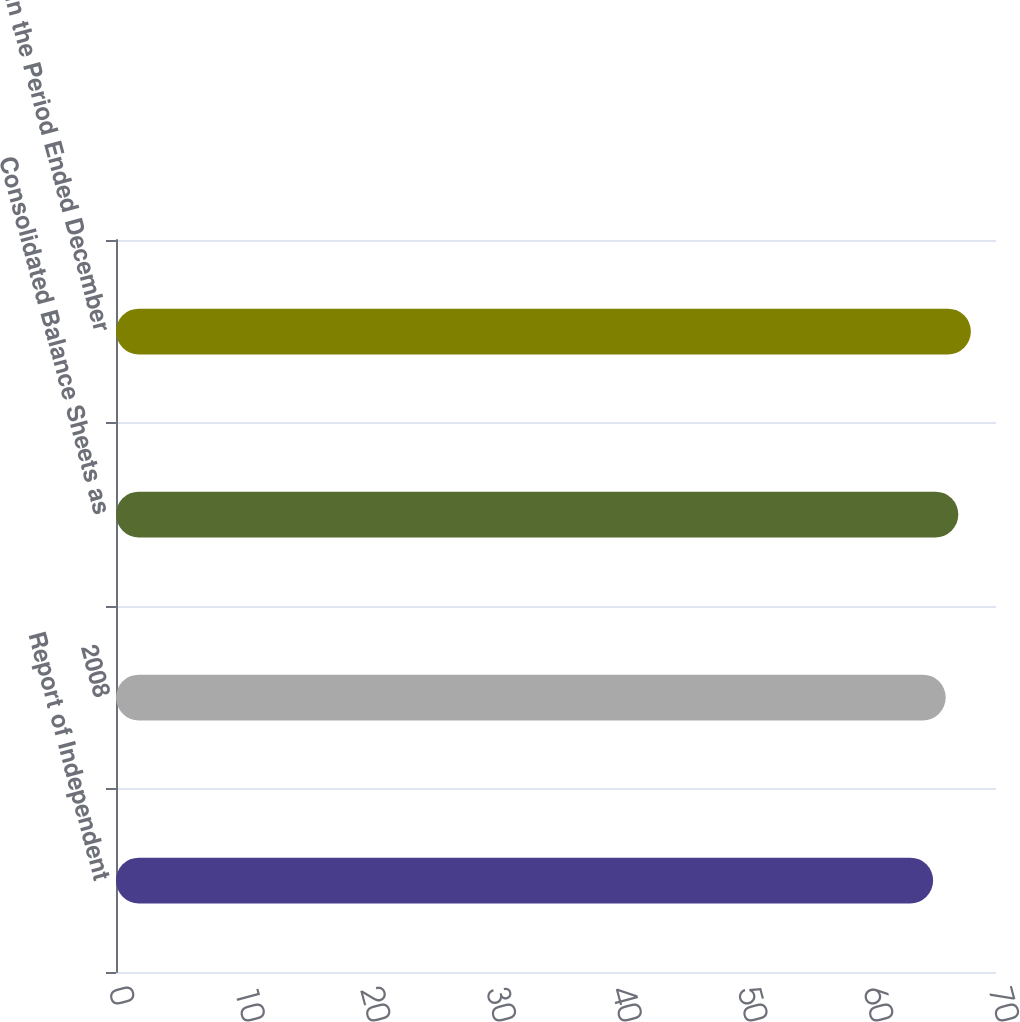Convert chart to OTSL. <chart><loc_0><loc_0><loc_500><loc_500><bar_chart><fcel>Report of Independent<fcel>2008<fcel>Consolidated Balance Sheets as<fcel>in the Period Ended December<nl><fcel>65<fcel>66<fcel>67<fcel>68<nl></chart> 